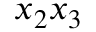<formula> <loc_0><loc_0><loc_500><loc_500>x _ { 2 } x _ { 3 }</formula> 